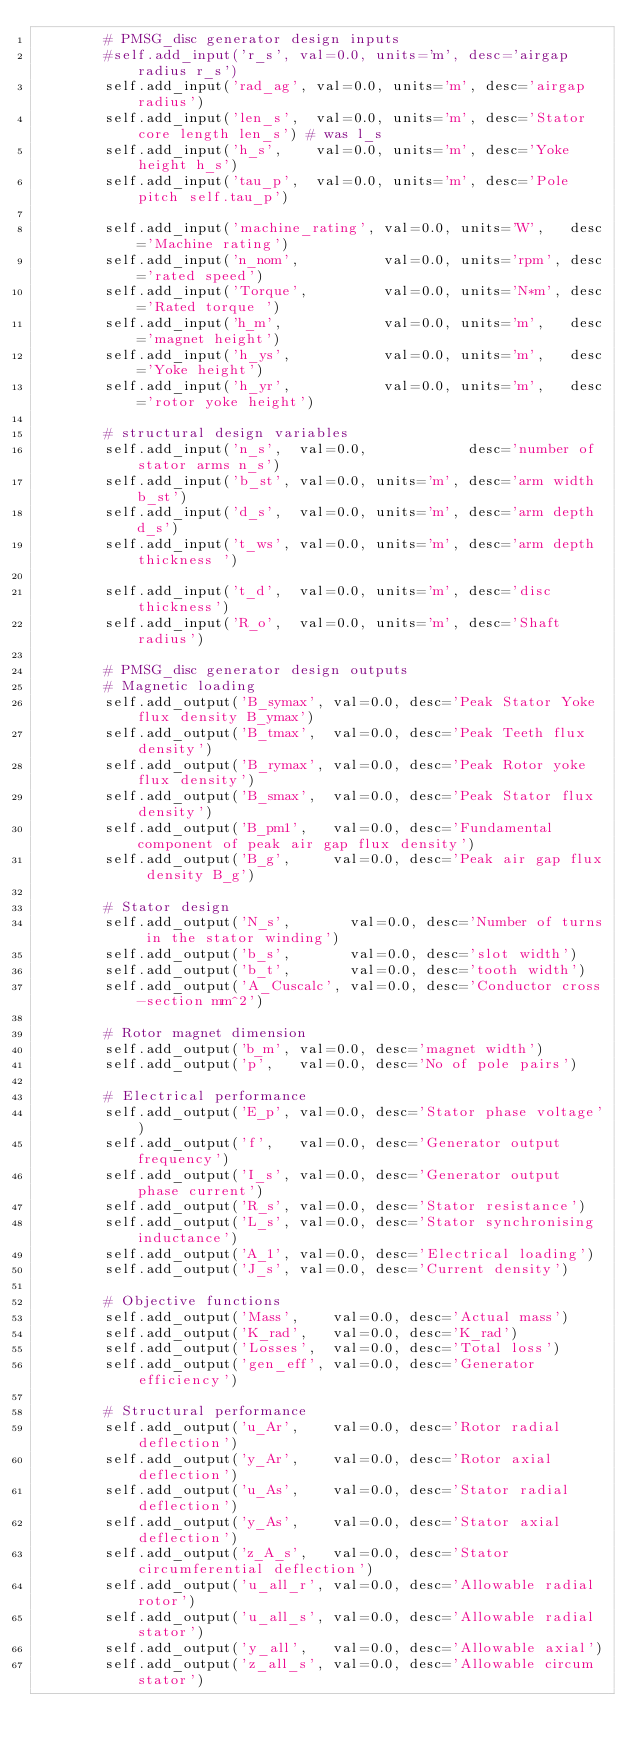<code> <loc_0><loc_0><loc_500><loc_500><_Python_>        # PMSG_disc generator design inputs
        #self.add_input('r_s', val=0.0, units='m', desc='airgap radius r_s')
        self.add_input('rad_ag', val=0.0, units='m', desc='airgap radius')
        self.add_input('len_s',  val=0.0, units='m', desc='Stator core length len_s') # was l_s
        self.add_input('h_s',    val=0.0, units='m', desc='Yoke height h_s')
        self.add_input('tau_p',  val=0.0, units='m', desc='Pole pitch self.tau_p')
        
        self.add_input('machine_rating', val=0.0, units='W',   desc='Machine rating')
        self.add_input('n_nom',          val=0.0, units='rpm', desc='rated speed')
        self.add_input('Torque',         val=0.0, units='N*m', desc='Rated torque ')
        self.add_input('h_m',            val=0.0, units='m',   desc='magnet height')
        self.add_input('h_ys',           val=0.0, units='m',   desc='Yoke height')
        self.add_input('h_yr',           val=0.0, units='m',   desc='rotor yoke height')
        
        # structural design variables
        self.add_input('n_s',  val=0.0,            desc='number of stator arms n_s')
        self.add_input('b_st', val=0.0, units='m', desc='arm width b_st')
        self.add_input('d_s',  val=0.0, units='m', desc='arm depth d_s')
        self.add_input('t_ws', val=0.0, units='m', desc='arm depth thickness ')
        
        self.add_input('t_d',  val=0.0, units='m', desc='disc thickness')
        self.add_input('R_o',  val=0.0, units='m', desc='Shaft radius')
        
        # PMSG_disc generator design outputs
        # Magnetic loading
        self.add_output('B_symax', val=0.0, desc='Peak Stator Yoke flux density B_ymax')
        self.add_output('B_tmax',  val=0.0, desc='Peak Teeth flux density')
        self.add_output('B_rymax', val=0.0, desc='Peak Rotor yoke flux density')
        self.add_output('B_smax',  val=0.0, desc='Peak Stator flux density')
        self.add_output('B_pm1',   val=0.0, desc='Fundamental component of peak air gap flux density')
        self.add_output('B_g',     val=0.0, desc='Peak air gap flux density B_g')
        
        # Stator design
        self.add_output('N_s',       val=0.0, desc='Number of turns in the stator winding')
        self.add_output('b_s',       val=0.0, desc='slot width')
        self.add_output('b_t',       val=0.0, desc='tooth width')
        self.add_output('A_Cuscalc', val=0.0, desc='Conductor cross-section mm^2')
        
        # Rotor magnet dimension
        self.add_output('b_m', val=0.0, desc='magnet width')
        self.add_output('p',   val=0.0, desc='No of pole pairs')
        
        # Electrical performance
        self.add_output('E_p', val=0.0, desc='Stator phase voltage')
        self.add_output('f',   val=0.0, desc='Generator output frequency')
        self.add_output('I_s', val=0.0, desc='Generator output phase current')
        self.add_output('R_s', val=0.0, desc='Stator resistance')
        self.add_output('L_s', val=0.0, desc='Stator synchronising inductance')
        self.add_output('A_1', val=0.0, desc='Electrical loading')
        self.add_output('J_s', val=0.0, desc='Current density')
        
        # Objective functions
        self.add_output('Mass',    val=0.0, desc='Actual mass')
        self.add_output('K_rad',   val=0.0, desc='K_rad')
        self.add_output('Losses',  val=0.0, desc='Total loss')
        self.add_output('gen_eff', val=0.0, desc='Generator efficiency')
    
        # Structural performance
        self.add_output('u_Ar',    val=0.0, desc='Rotor radial deflection')
        self.add_output('y_Ar',    val=0.0, desc='Rotor axial deflection')
        self.add_output('u_As',    val=0.0, desc='Stator radial deflection')
        self.add_output('y_As',    val=0.0, desc='Stator axial deflection')
        self.add_output('z_A_s',   val=0.0, desc='Stator circumferential deflection')  
        self.add_output('u_all_r', val=0.0, desc='Allowable radial rotor')
        self.add_output('u_all_s', val=0.0, desc='Allowable radial stator')
        self.add_output('y_all',   val=0.0, desc='Allowable axial')
        self.add_output('z_all_s', val=0.0, desc='Allowable circum stator')</code> 